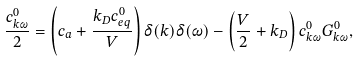Convert formula to latex. <formula><loc_0><loc_0><loc_500><loc_500>\frac { c _ { k \omega } ^ { 0 } } { 2 } = \left ( c _ { a } + \frac { k _ { D } c _ { e q } ^ { 0 } } { V } \right ) \delta ( k ) \delta ( \omega ) - \left ( \frac { V } { 2 } + k _ { D } \right ) c _ { k \omega } ^ { 0 } G _ { k \omega } ^ { 0 } ,</formula> 